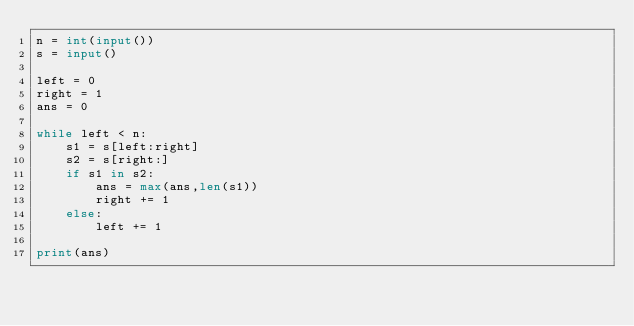Convert code to text. <code><loc_0><loc_0><loc_500><loc_500><_Python_>n = int(input())
s = input()

left = 0
right = 1
ans = 0

while left < n:
    s1 = s[left:right]
    s2 = s[right:]
    if s1 in s2:
        ans = max(ans,len(s1))
        right += 1
    else:
        left += 1

print(ans)</code> 